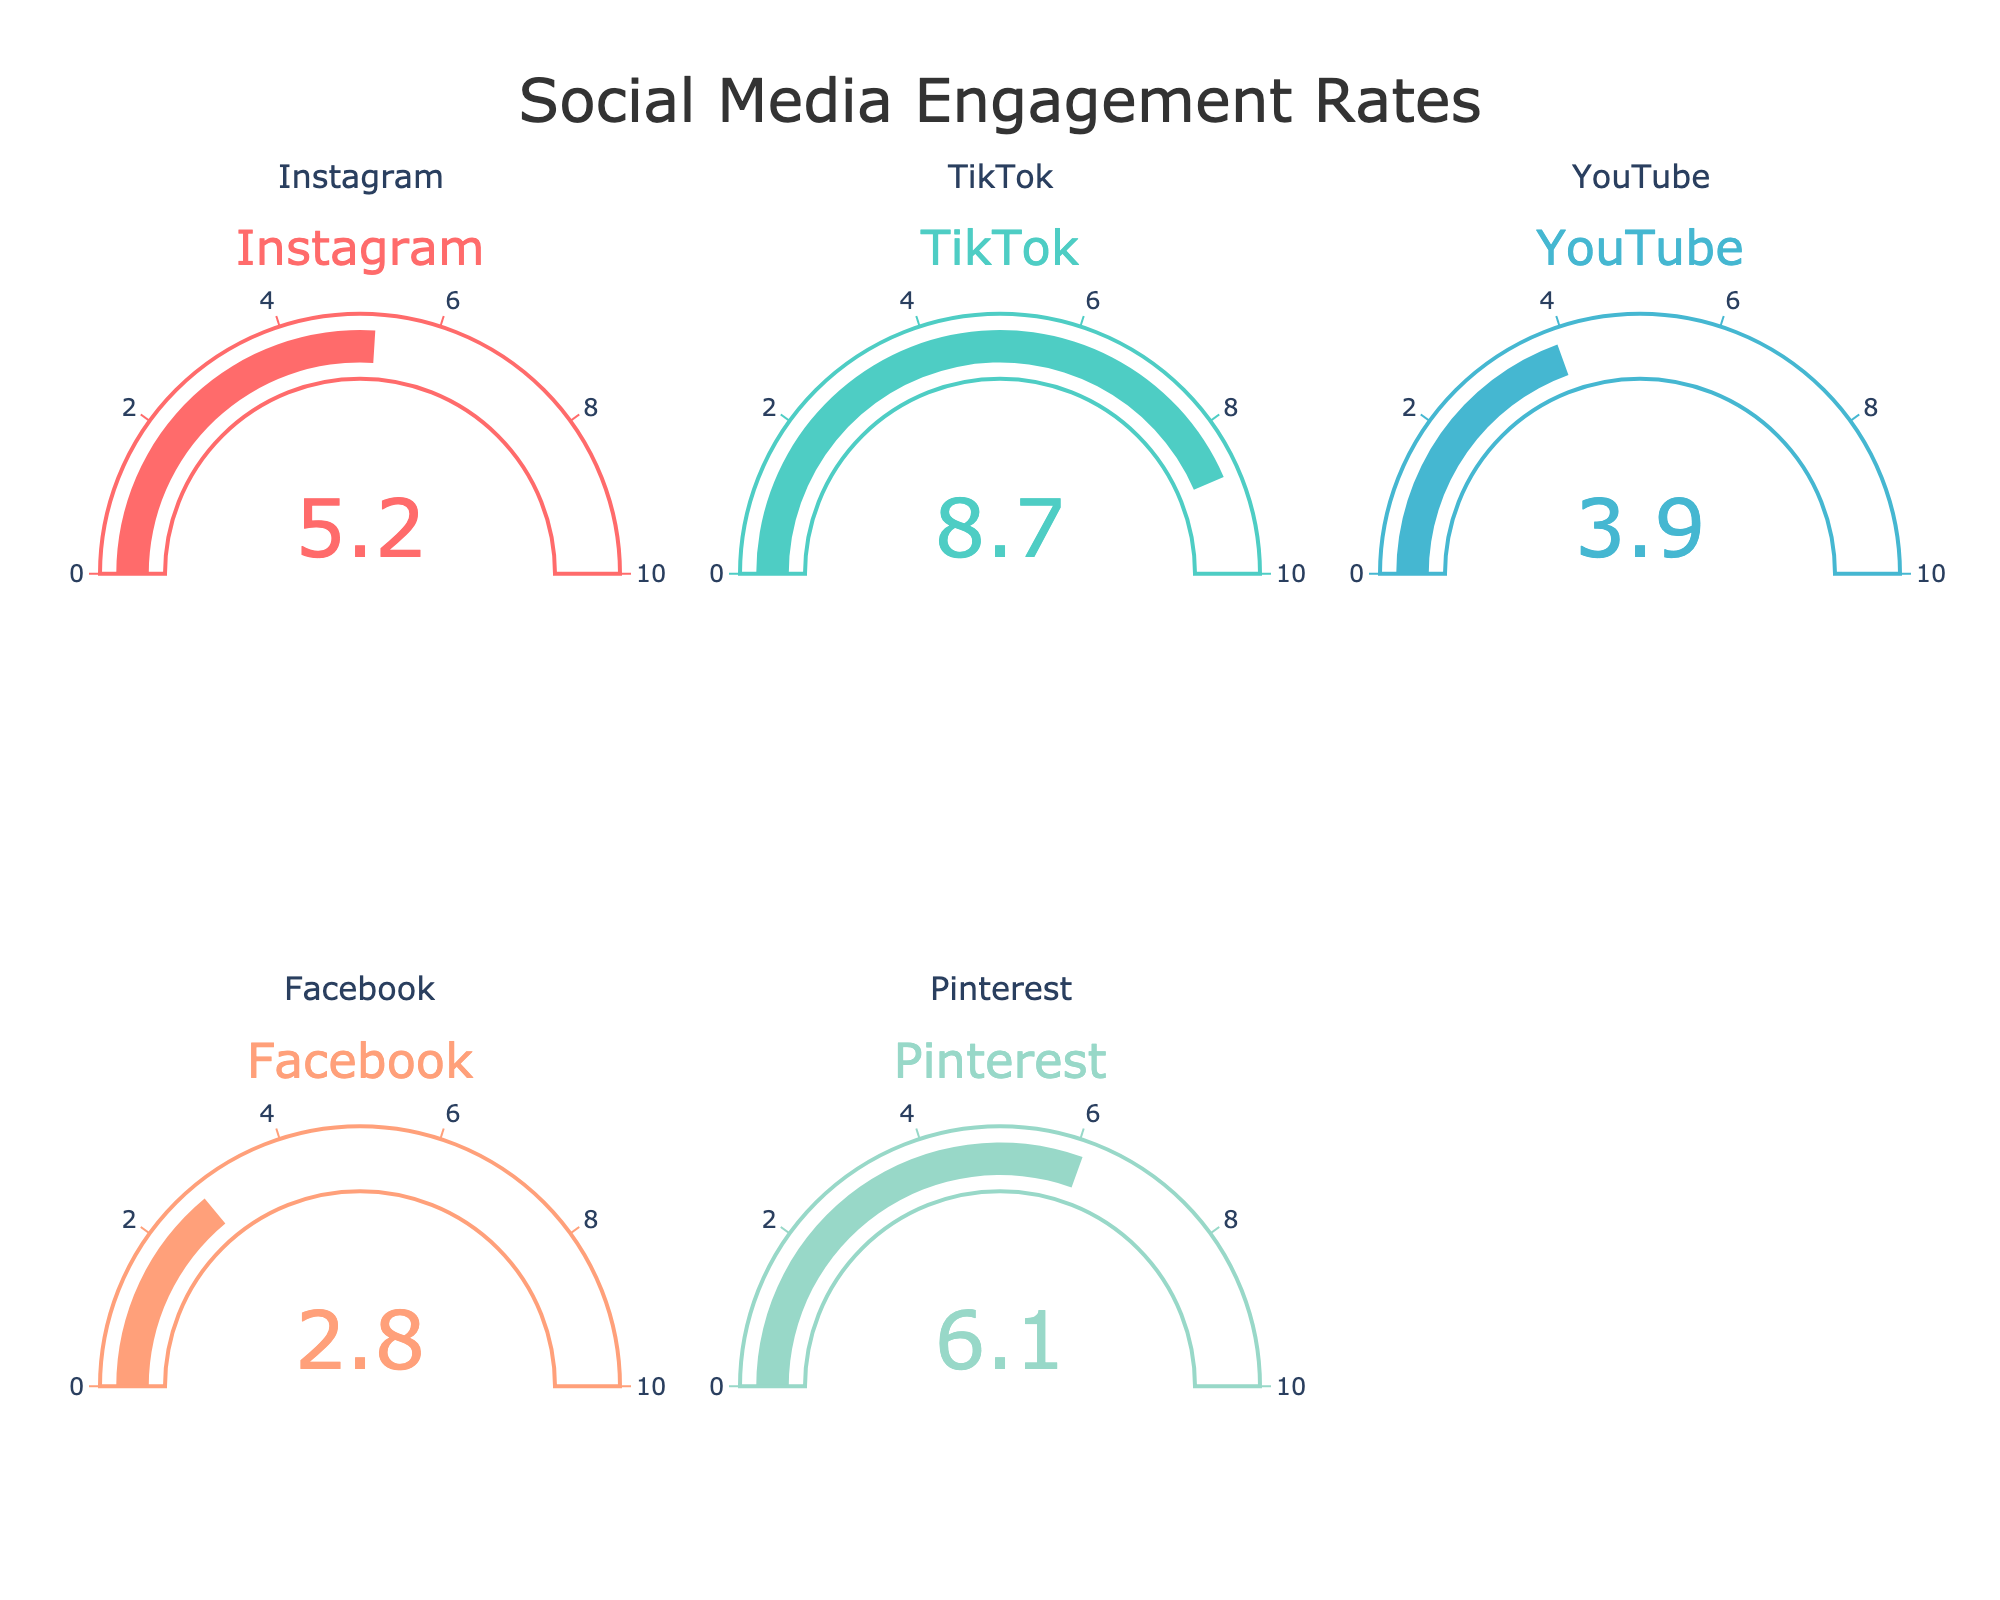What is the engagement rate for Instagram? The gauge chart labeled "Instagram" shows a value of 5.2 near the center.
Answer: 5.2 Which social media platform has the highest engagement rate? By comparing the values on all the gauges, TikTok shows the highest engagement rate of 8.7.
Answer: TikTok What is the difference in engagement rates between TikTok and YouTube? TikTok has an engagement rate of 8.7, and YouTube has 3.9. Subtracting YouTube's rate from TikTok's rate (8.7 - 3.9) gives 4.8.
Answer: 4.8 Which platform has the lowest engagement rate? The platform with the lowest value on its gauge chart is Facebook, which shows an engagement rate of 2.8.
Answer: Facebook What is the average engagement rate across all platforms? Sum the engagement rates (5.2 + 8.7 + 3.9 + 2.8 + 6.1) to get 26.7, then divide by the number of platforms (5) which gives 26.7/5 = 5.34.
Answer: 5.34 What color is used for the TikTok engagement rate gauge? The TikTok gauge is represented by the color shown in the "TikTok" gauge chart, which has a cyan/teal tint.
Answer: Cyan/Teal How much higher is Pinterest’s engagement rate compared to Facebook’s? Pinterest’s engagement rate is listed at 6.1, and Facebook’s at 2.8. Subtract Facebook's rate from Pinterest's rate (6.1 - 2.8) to get 3.3.
Answer: 3.3 What is the engagement rate for the fifth platform in the figure? The fifth platform listed, which is Pinterest, has an engagement rate of 6.1.
Answer: 6.1 